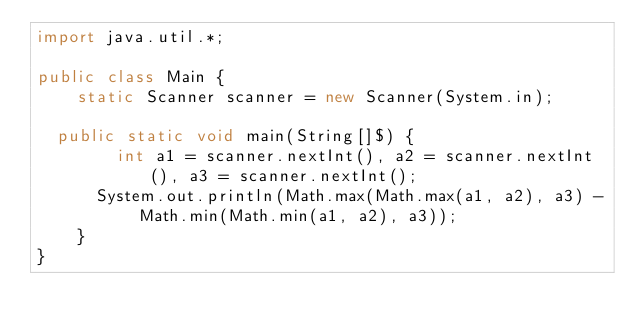<code> <loc_0><loc_0><loc_500><loc_500><_Java_>import java.util.*;

public class Main {
  	static Scanner scanner = new Scanner(System.in);
  
	public static void main(String[]$) {
      	int a1 = scanner.nextInt(), a2 = scanner.nextInt(), a3 = scanner.nextInt();
    	System.out.println(Math.max(Math.max(a1, a2), a3) - Math.min(Math.min(a1, a2), a3));
    }
}</code> 